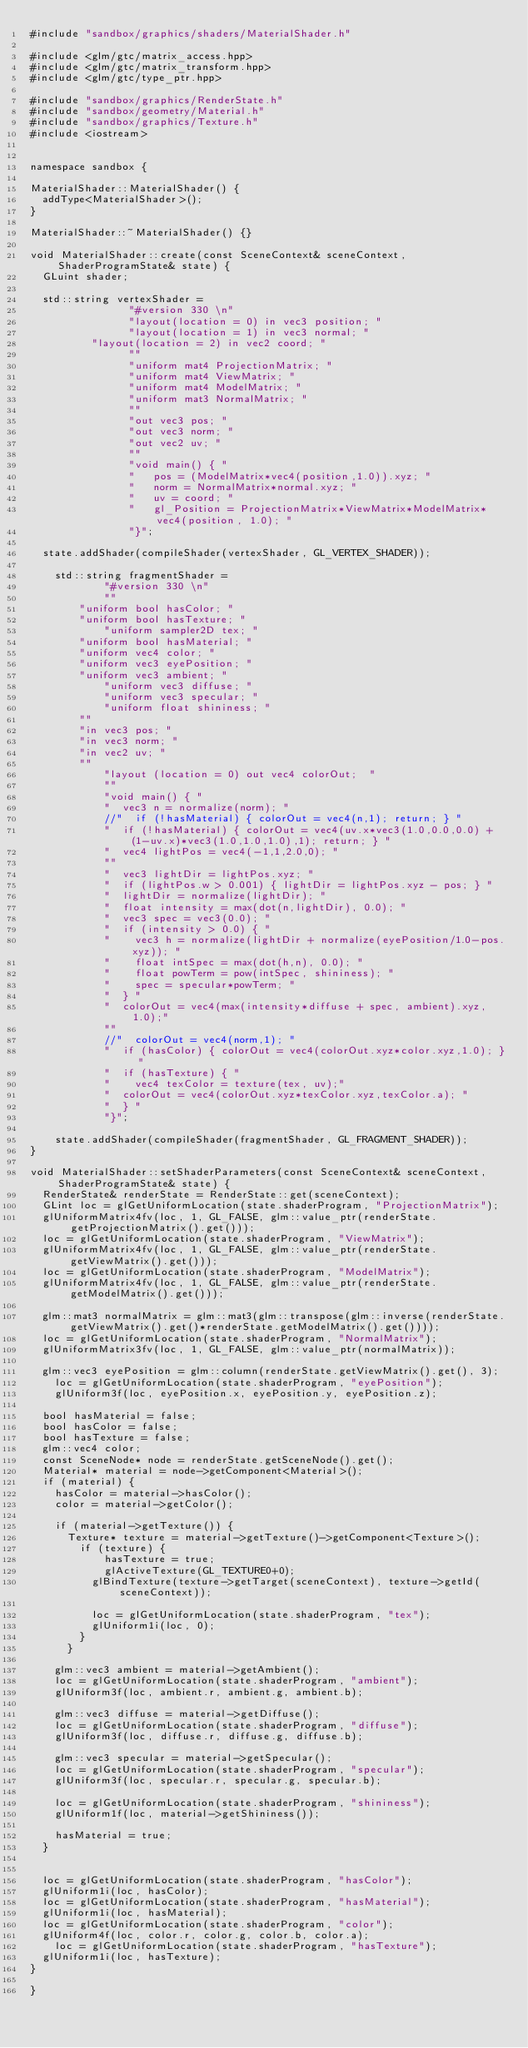Convert code to text. <code><loc_0><loc_0><loc_500><loc_500><_C++_>#include "sandbox/graphics/shaders/MaterialShader.h"

#include <glm/gtc/matrix_access.hpp>
#include <glm/gtc/matrix_transform.hpp>
#include <glm/gtc/type_ptr.hpp>

#include "sandbox/graphics/RenderState.h"
#include "sandbox/geometry/Material.h"
#include "sandbox/graphics/Texture.h"
#include <iostream>


namespace sandbox {

MaterialShader::MaterialShader() {
	addType<MaterialShader>();
}

MaterialShader::~MaterialShader() {}

void MaterialShader::create(const SceneContext& sceneContext, ShaderProgramState& state) {
	GLuint shader;

	std::string vertexShader =
		            "#version 330 \n"
		            "layout(location = 0) in vec3 position; "
		            "layout(location = 1) in vec3 normal; "
					"layout(location = 2) in vec2 coord; "
		            ""
		            "uniform mat4 ProjectionMatrix; "
		            "uniform mat4 ViewMatrix; "
		            "uniform mat4 ModelMatrix; "
		            "uniform mat3 NormalMatrix; "
		            ""
		            "out vec3 pos; "
		            "out vec3 norm; "
		            "out vec2 uv; "
		            ""
		            "void main() { "
		            "   pos = (ModelMatrix*vec4(position,1.0)).xyz; "
		            "   norm = NormalMatrix*normal.xyz; "
		            "   uv = coord; "
		            "   gl_Position = ProjectionMatrix*ViewMatrix*ModelMatrix*vec4(position, 1.0); "
		            "}";

	state.addShader(compileShader(vertexShader, GL_VERTEX_SHADER));

    std::string fragmentShader =
            "#version 330 \n"
            ""
		    "uniform bool hasColor; "
		    "uniform bool hasTexture; "
            "uniform sampler2D tex; "
		    "uniform bool hasMaterial; "
		    "uniform vec4 color; "
		    "uniform vec3 eyePosition; "
		    "uniform vec3 ambient; "
            "uniform vec3 diffuse; "
            "uniform vec3 specular; "
            "uniform float shininess; "
		    ""
		    "in vec3 pos; "
		    "in vec3 norm; "
		    "in vec2 uv; "
		    ""
            "layout (location = 0) out vec4 colorOut;  "
            ""
            "void main() { "
            "  vec3 n = normalize(norm); "
            //"  if (!hasMaterial) { colorOut = vec4(n,1); return; } "
            "  if (!hasMaterial) { colorOut = vec4(uv.x*vec3(1.0,0.0,0.0) + (1-uv.x)*vec3(1.0,1.0,1.0),1); return; } "
            "  vec4 lightPos = vec4(-1,1,2.0,0); "
            ""
            "  vec3 lightDir = lightPos.xyz; "
            "  if (lightPos.w > 0.001) { lightDir = lightPos.xyz - pos; } "
            "  lightDir = normalize(lightDir); "
            "  float intensity = max(dot(n,lightDir), 0.0); "
            "  vec3 spec = vec3(0.0); "
            "  if (intensity > 0.0) { "
            "    vec3 h = normalize(lightDir + normalize(eyePosition/1.0-pos.xyz)); "
            "    float intSpec = max(dot(h,n), 0.0); "
            "    float powTerm = pow(intSpec, shininess); "
            "    spec = specular*powTerm; "
            "  } "
            "  colorOut = vec4(max(intensity*diffuse + spec, ambient).xyz, 1.0);"
            ""
            //"  colorOut = vec4(norm,1); "
            "  if (hasColor) { colorOut = vec4(colorOut.xyz*color.xyz,1.0); } "
            "  if (hasTexture) { "
            "    vec4 texColor = texture(tex, uv);"
            "	 colorOut = vec4(colorOut.xyz*texColor.xyz,texColor.a); "
            "  } "
            "}";

    state.addShader(compileShader(fragmentShader, GL_FRAGMENT_SHADER));
}

void MaterialShader::setShaderParameters(const SceneContext& sceneContext, ShaderProgramState& state) {
	RenderState& renderState = RenderState::get(sceneContext);
	GLint loc = glGetUniformLocation(state.shaderProgram, "ProjectionMatrix");
	glUniformMatrix4fv(loc, 1, GL_FALSE, glm::value_ptr(renderState.getProjectionMatrix().get()));
	loc = glGetUniformLocation(state.shaderProgram, "ViewMatrix");
	glUniformMatrix4fv(loc, 1, GL_FALSE, glm::value_ptr(renderState.getViewMatrix().get()));
	loc = glGetUniformLocation(state.shaderProgram, "ModelMatrix");
	glUniformMatrix4fv(loc, 1, GL_FALSE, glm::value_ptr(renderState.getModelMatrix().get()));

	glm::mat3 normalMatrix = glm::mat3(glm::transpose(glm::inverse(renderState.getViewMatrix().get()*renderState.getModelMatrix().get())));
	loc = glGetUniformLocation(state.shaderProgram, "NormalMatrix");
	glUniformMatrix3fv(loc, 1, GL_FALSE, glm::value_ptr(normalMatrix));

	glm::vec3 eyePosition = glm::column(renderState.getViewMatrix().get(), 3);
    loc = glGetUniformLocation(state.shaderProgram, "eyePosition");
    glUniform3f(loc, eyePosition.x, eyePosition.y, eyePosition.z);

	bool hasMaterial = false;
	bool hasColor = false;
	bool hasTexture = false;
	glm::vec4 color;
	const SceneNode* node = renderState.getSceneNode().get();
	Material* material = node->getComponent<Material>();
	if (material) {
		hasColor = material->hasColor();
		color = material->getColor();

		if (material->getTexture()) {
			Texture* texture = material->getTexture()->getComponent<Texture>();
	    	if (texture) {
		    		hasTexture = true;
	    			glActiveTexture(GL_TEXTURE0+0);
					glBindTexture(texture->getTarget(sceneContext), texture->getId(sceneContext));

					loc = glGetUniformLocation(state.shaderProgram, "tex");
					glUniform1i(loc, 0);
	    	}
	    }

		glm::vec3 ambient = material->getAmbient();
		loc = glGetUniformLocation(state.shaderProgram, "ambient");
		glUniform3f(loc, ambient.r, ambient.g, ambient.b);

		glm::vec3 diffuse = material->getDiffuse();
		loc = glGetUniformLocation(state.shaderProgram, "diffuse");
		glUniform3f(loc, diffuse.r, diffuse.g, diffuse.b);

		glm::vec3 specular = material->getSpecular();
		loc = glGetUniformLocation(state.shaderProgram, "specular");
		glUniform3f(loc, specular.r, specular.g, specular.b);

		loc = glGetUniformLocation(state.shaderProgram, "shininess");
		glUniform1f(loc, material->getShininess());

		hasMaterial = true;
	}


	loc = glGetUniformLocation(state.shaderProgram, "hasColor");
	glUniform1i(loc, hasColor);
	loc = glGetUniformLocation(state.shaderProgram, "hasMaterial");
	glUniform1i(loc, hasMaterial);
	loc = glGetUniformLocation(state.shaderProgram, "color");
	glUniform4f(loc, color.r, color.g, color.b, color.a);
    loc = glGetUniformLocation(state.shaderProgram, "hasTexture");
	glUniform1i(loc, hasTexture);
}

}</code> 